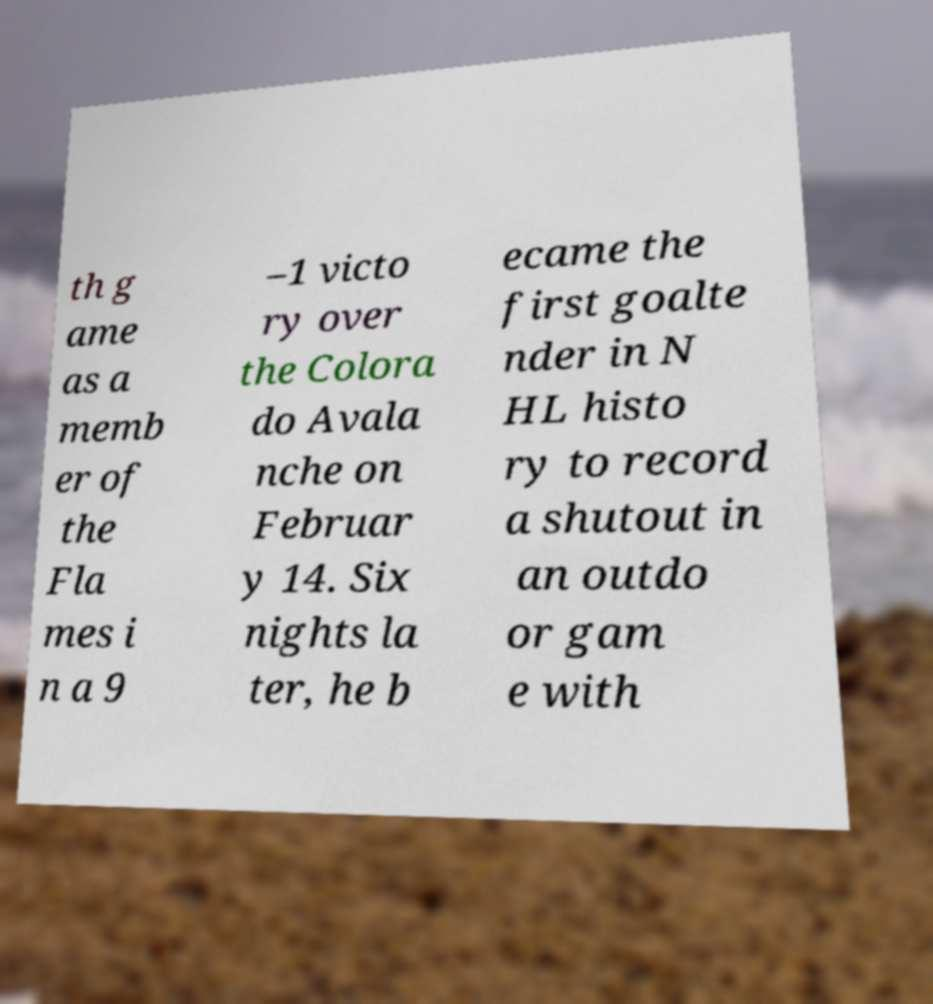I need the written content from this picture converted into text. Can you do that? th g ame as a memb er of the Fla mes i n a 9 –1 victo ry over the Colora do Avala nche on Februar y 14. Six nights la ter, he b ecame the first goalte nder in N HL histo ry to record a shutout in an outdo or gam e with 